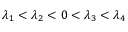Convert formula to latex. <formula><loc_0><loc_0><loc_500><loc_500>\lambda _ { 1 } < \lambda _ { 2 } < 0 < \lambda _ { 3 } < \lambda _ { 4 }</formula> 